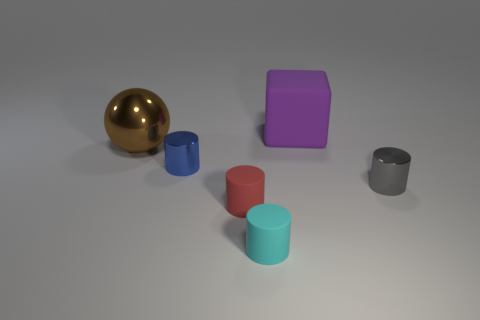What is the material of the small cylinder that is behind the small shiny object right of the small shiny thing that is to the left of the small red cylinder?
Provide a succinct answer. Metal. How many other gray cylinders have the same material as the gray cylinder?
Offer a terse response. 0. Is the size of the matte thing behind the brown thing the same as the small red rubber thing?
Ensure brevity in your answer.  No. What is the color of the block that is the same material as the cyan cylinder?
Ensure brevity in your answer.  Purple. There is a large sphere; how many rubber objects are behind it?
Your answer should be very brief. 1. There is another shiny object that is the same shape as the small blue object; what is its color?
Keep it short and to the point. Gray. Is there any other thing that has the same shape as the large rubber thing?
Give a very brief answer. No. There is a tiny metal thing that is to the right of the small cyan cylinder; does it have the same shape as the thing behind the large sphere?
Make the answer very short. No. There is a red object; is its size the same as the metallic cylinder on the right side of the blue shiny cylinder?
Your answer should be very brief. Yes. Is the number of large brown spheres greater than the number of small gray blocks?
Ensure brevity in your answer.  Yes. 